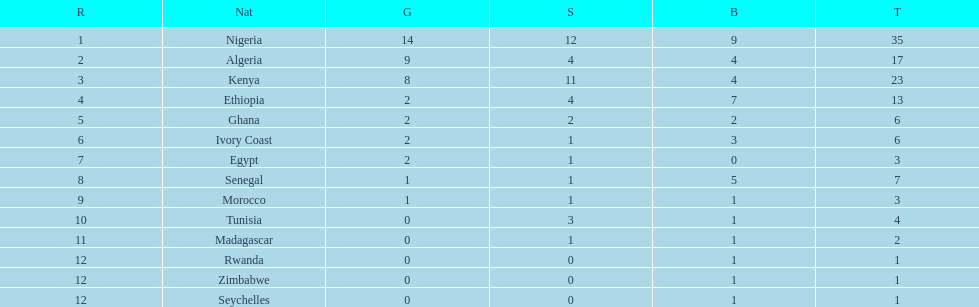Total number of bronze medals nigeria earned? 9. 